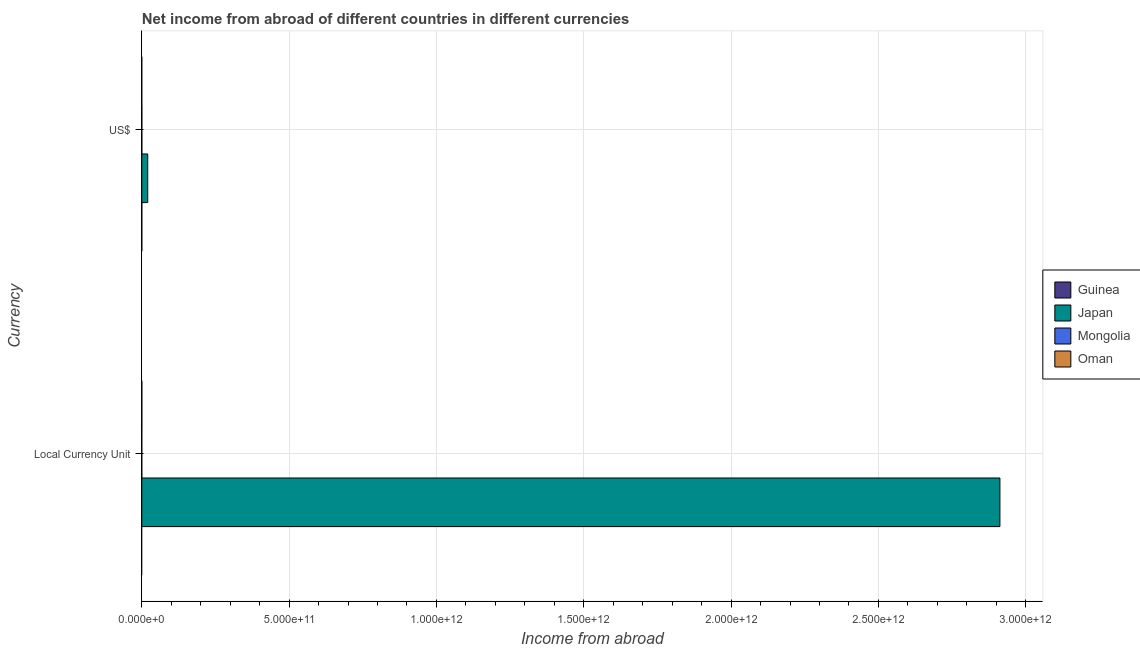Are the number of bars on each tick of the Y-axis equal?
Your answer should be very brief. Yes. How many bars are there on the 2nd tick from the bottom?
Ensure brevity in your answer.  1. What is the label of the 1st group of bars from the top?
Give a very brief answer. US$. Across all countries, what is the maximum income from abroad in us$?
Keep it short and to the point. 2.01e+1. What is the total income from abroad in constant 2005 us$ in the graph?
Your response must be concise. 2.91e+12. What is the difference between the income from abroad in us$ in Oman and the income from abroad in constant 2005 us$ in Japan?
Your response must be concise. -2.91e+12. What is the average income from abroad in us$ per country?
Ensure brevity in your answer.  5.03e+09. What is the difference between the income from abroad in us$ and income from abroad in constant 2005 us$ in Japan?
Offer a very short reply. -2.89e+12. In how many countries, is the income from abroad in constant 2005 us$ greater than 600000000000 units?
Keep it short and to the point. 1. How many bars are there?
Your response must be concise. 2. How many countries are there in the graph?
Provide a short and direct response. 4. What is the difference between two consecutive major ticks on the X-axis?
Provide a succinct answer. 5.00e+11. Does the graph contain any zero values?
Your answer should be very brief. Yes. Where does the legend appear in the graph?
Offer a terse response. Center right. How are the legend labels stacked?
Offer a terse response. Vertical. What is the title of the graph?
Your answer should be compact. Net income from abroad of different countries in different currencies. Does "Morocco" appear as one of the legend labels in the graph?
Your answer should be very brief. No. What is the label or title of the X-axis?
Offer a very short reply. Income from abroad. What is the label or title of the Y-axis?
Offer a terse response. Currency. What is the Income from abroad of Guinea in Local Currency Unit?
Your response must be concise. 0. What is the Income from abroad of Japan in Local Currency Unit?
Provide a short and direct response. 2.91e+12. What is the Income from abroad in Japan in US$?
Provide a succinct answer. 2.01e+1. What is the Income from abroad of Mongolia in US$?
Ensure brevity in your answer.  0. What is the Income from abroad in Oman in US$?
Your answer should be compact. 0. Across all Currency, what is the maximum Income from abroad of Japan?
Your response must be concise. 2.91e+12. Across all Currency, what is the minimum Income from abroad of Japan?
Offer a terse response. 2.01e+1. What is the total Income from abroad in Guinea in the graph?
Your answer should be compact. 0. What is the total Income from abroad of Japan in the graph?
Your response must be concise. 2.93e+12. What is the total Income from abroad in Oman in the graph?
Ensure brevity in your answer.  0. What is the difference between the Income from abroad of Japan in Local Currency Unit and that in US$?
Make the answer very short. 2.89e+12. What is the average Income from abroad in Japan per Currency?
Your response must be concise. 1.47e+12. What is the average Income from abroad of Mongolia per Currency?
Make the answer very short. 0. What is the average Income from abroad of Oman per Currency?
Provide a succinct answer. 0. What is the ratio of the Income from abroad in Japan in Local Currency Unit to that in US$?
Offer a terse response. 144.79. What is the difference between the highest and the second highest Income from abroad of Japan?
Ensure brevity in your answer.  2.89e+12. What is the difference between the highest and the lowest Income from abroad in Japan?
Make the answer very short. 2.89e+12. 